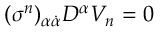<formula> <loc_0><loc_0><loc_500><loc_500>( \sigma ^ { n } ) _ { \alpha \dot { \alpha } } D ^ { \alpha } V _ { n } = 0</formula> 